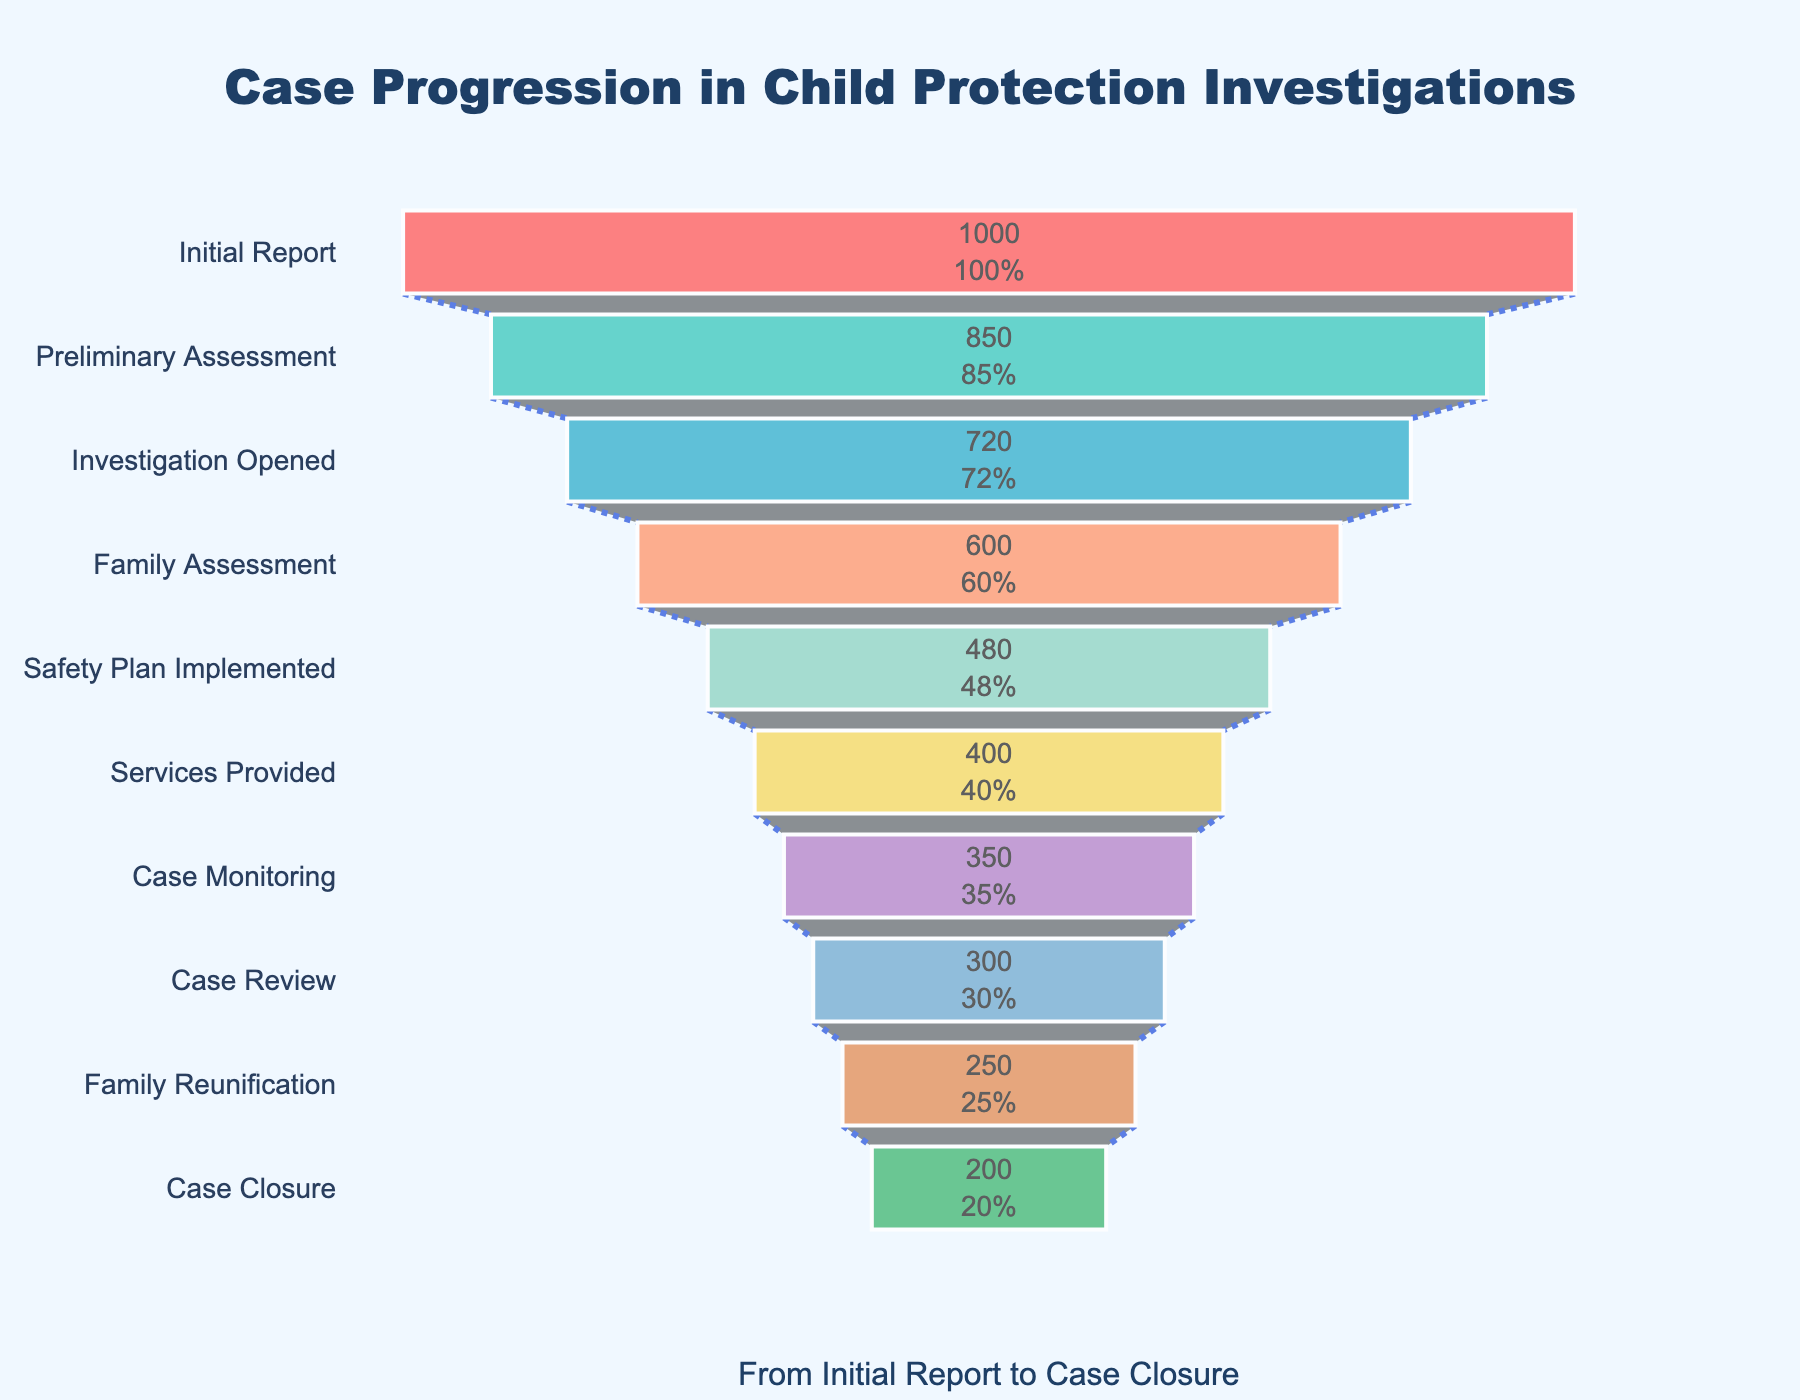What is the title of the funnel chart? The title is prominently displayed at the top of the chart, centered and in a larger font compared to other text elements.
Answer: Case Progression in Child Protection Investigations How many stages are there in the case progression? Count the number of stages listed on the y-axis of the funnel chart.
Answer: 10 What color scheme is used in the chart? Identify the different colors used in the segments of the funnel chart.
Answer: Multiple colors including shades of red, turquoise, blue, salmon, green, yellow, purple, light blue, orange, and green Which stage has the highest number of cases? Look at the top segment of the funnel chart, which represents the stage with the highest number of cases.
Answer: Initial Report How many cases reach the 'Family Reunification' stage? Find the segment labeled 'Family Reunification' and note the number of cases indicated within it.
Answer: 250 What is the percentage decrease from 'Initial Report' to 'Preliminary Assessment'? Calculate the percentage decrease based on the numbers provided: (1000 - 850) / 1000 * 100.
Answer: 15% What is the total number of closed cases? Identify the 'Case Closure' segment and read the number of cases from it.
Answer: 200 Which stage experiences the largest drop in the number of cases? Compare the differences between consecutive stages by subtracting the number of cases in the lower stage from the number in the upper stage, and identify the largest difference.
Answer: 'Family Assessment' to 'Safety Plan Implemented' What percentage of cases progress from 'Preliminary Assessment' to 'Investigation Opened'? Calculate the percentage of cases that move from 'Preliminary Assessment' (850) to 'Investigation Opened' (720): (720 / 850) * 100.
Answer: 84.71% Are there more cases at the 'Services Provided' stage or the 'Case Review' stage? Compare the number of cases in the 'Services Provided' and 'Case Review' segments.
Answer: More cases at 'Services Provided' 